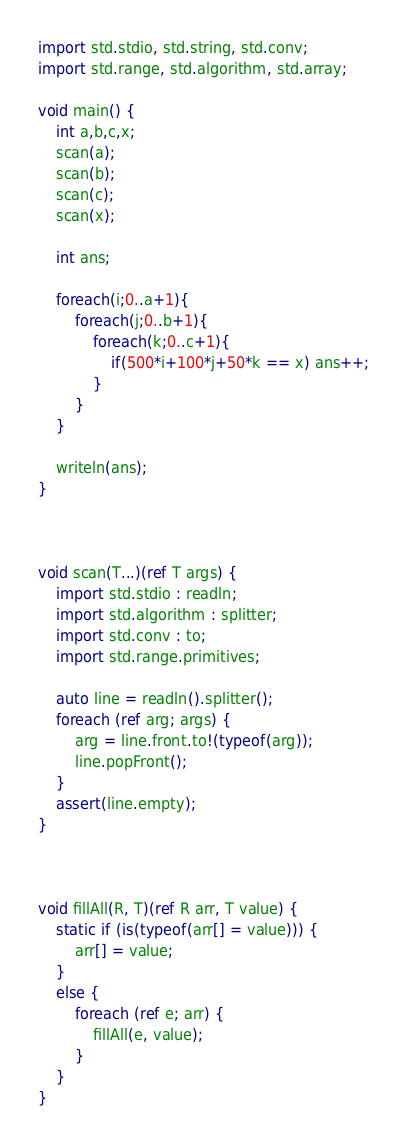<code> <loc_0><loc_0><loc_500><loc_500><_D_>import std.stdio, std.string, std.conv;
import std.range, std.algorithm, std.array;

void main() {
    int a,b,c,x;
    scan(a);
    scan(b);
    scan(c);
    scan(x);

    int ans;

    foreach(i;0..a+1){
        foreach(j;0..b+1){
            foreach(k;0..c+1){
                if(500*i+100*j+50*k == x) ans++;
            }
        }
    }

    writeln(ans);
}



void scan(T...)(ref T args) {
    import std.stdio : readln;
    import std.algorithm : splitter;
    import std.conv : to;
    import std.range.primitives;

    auto line = readln().splitter();
    foreach (ref arg; args) {
        arg = line.front.to!(typeof(arg));
        line.popFront();
    }
    assert(line.empty);
}



void fillAll(R, T)(ref R arr, T value) {
    static if (is(typeof(arr[] = value))) {
        arr[] = value;
    }
    else {
        foreach (ref e; arr) {
            fillAll(e, value);
        }
    }
}
</code> 